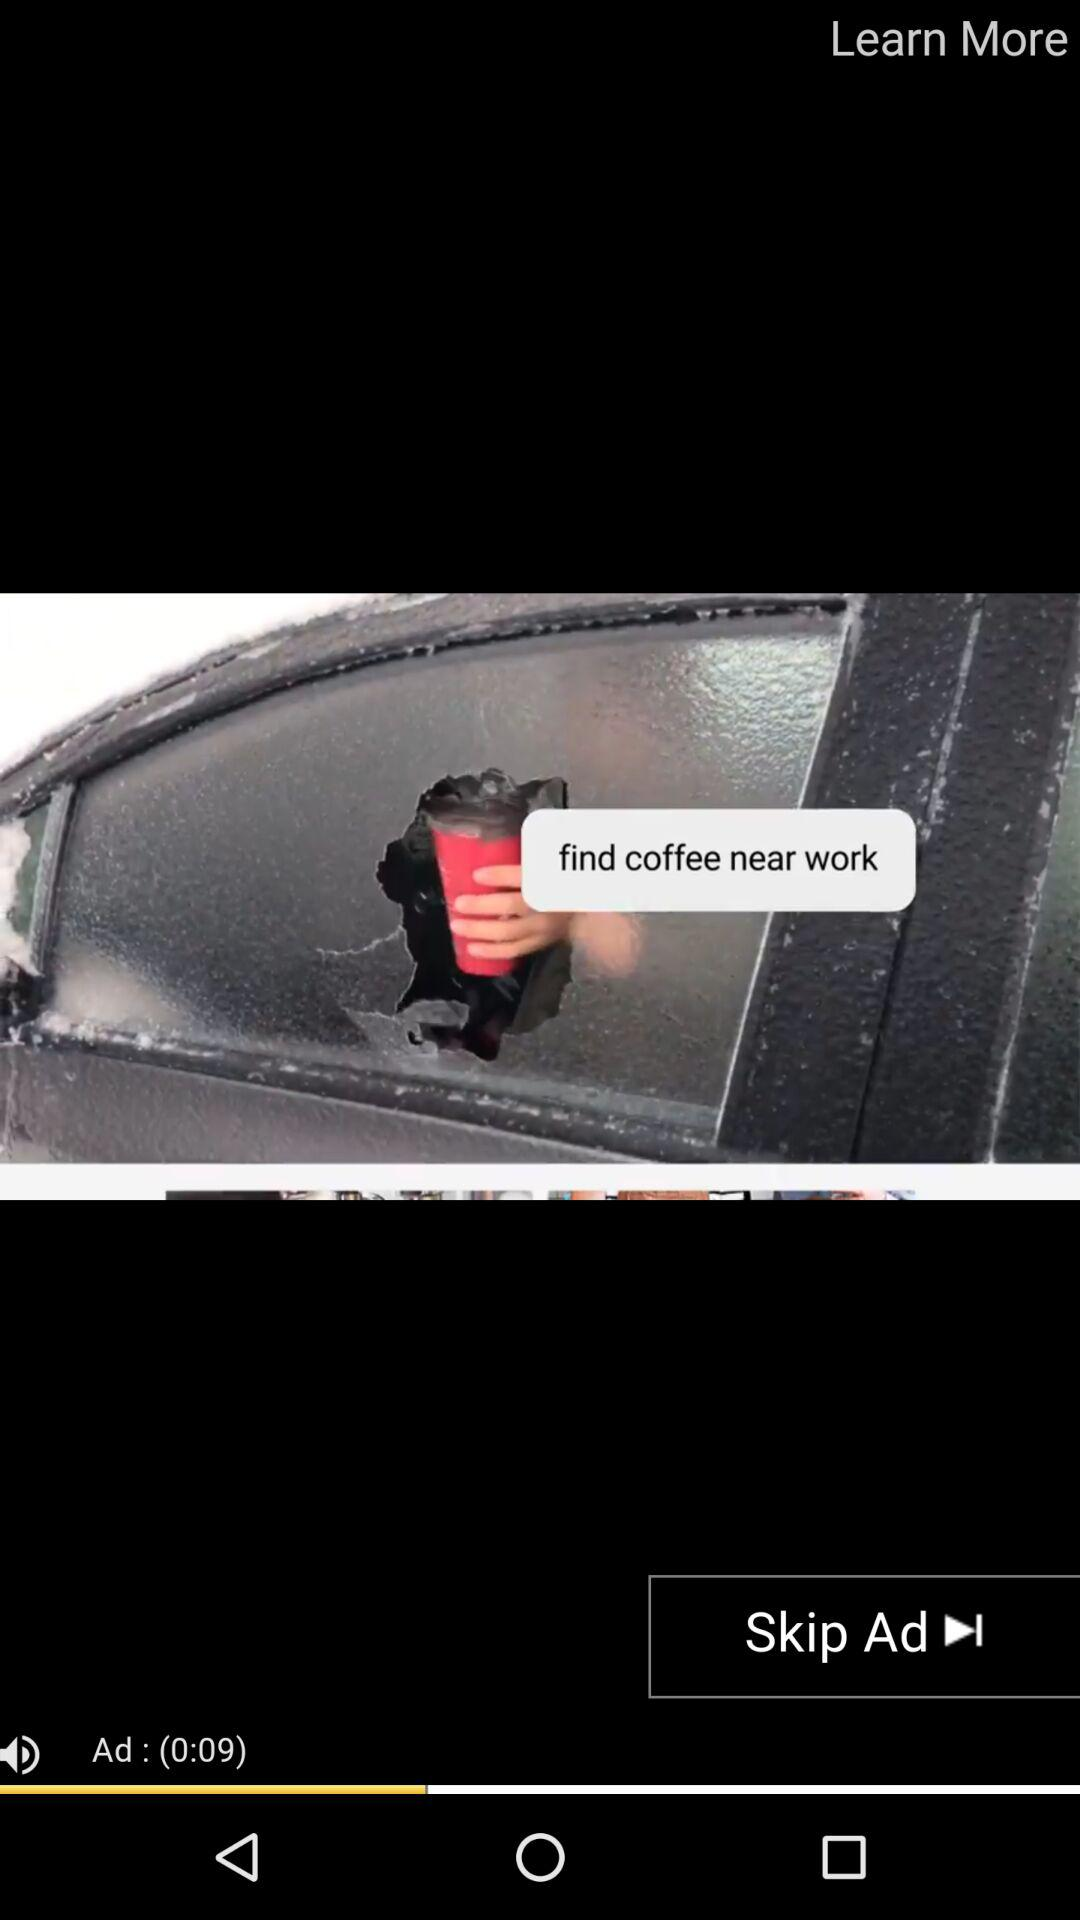How many seconds is the ad?
Answer the question using a single word or phrase. 9 